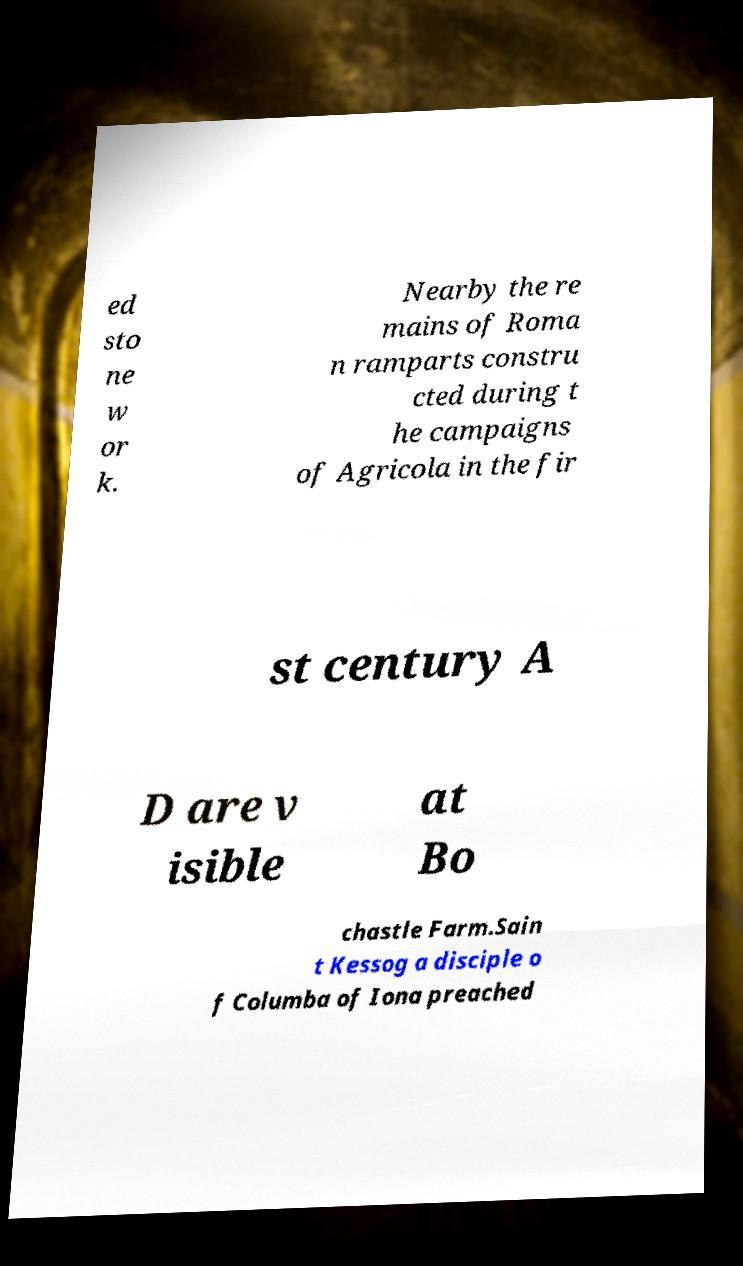Can you read and provide the text displayed in the image?This photo seems to have some interesting text. Can you extract and type it out for me? ed sto ne w or k. Nearby the re mains of Roma n ramparts constru cted during t he campaigns of Agricola in the fir st century A D are v isible at Bo chastle Farm.Sain t Kessog a disciple o f Columba of Iona preached 